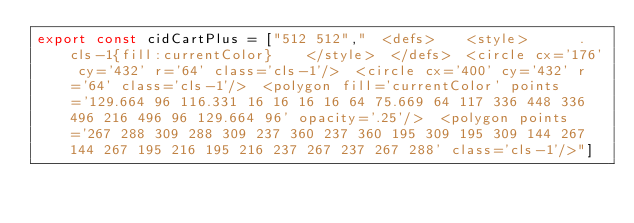<code> <loc_0><loc_0><loc_500><loc_500><_JavaScript_>export const cidCartPlus = ["512 512","  <defs>    <style>      .cls-1{fill:currentColor}    </style>  </defs>  <circle cx='176' cy='432' r='64' class='cls-1'/>  <circle cx='400' cy='432' r='64' class='cls-1'/>  <polygon fill='currentColor' points='129.664 96 116.331 16 16 16 16 64 75.669 64 117 336 448 336 496 216 496 96 129.664 96' opacity='.25'/>  <polygon points='267 288 309 288 309 237 360 237 360 195 309 195 309 144 267 144 267 195 216 195 216 237 267 237 267 288' class='cls-1'/>"]</code> 